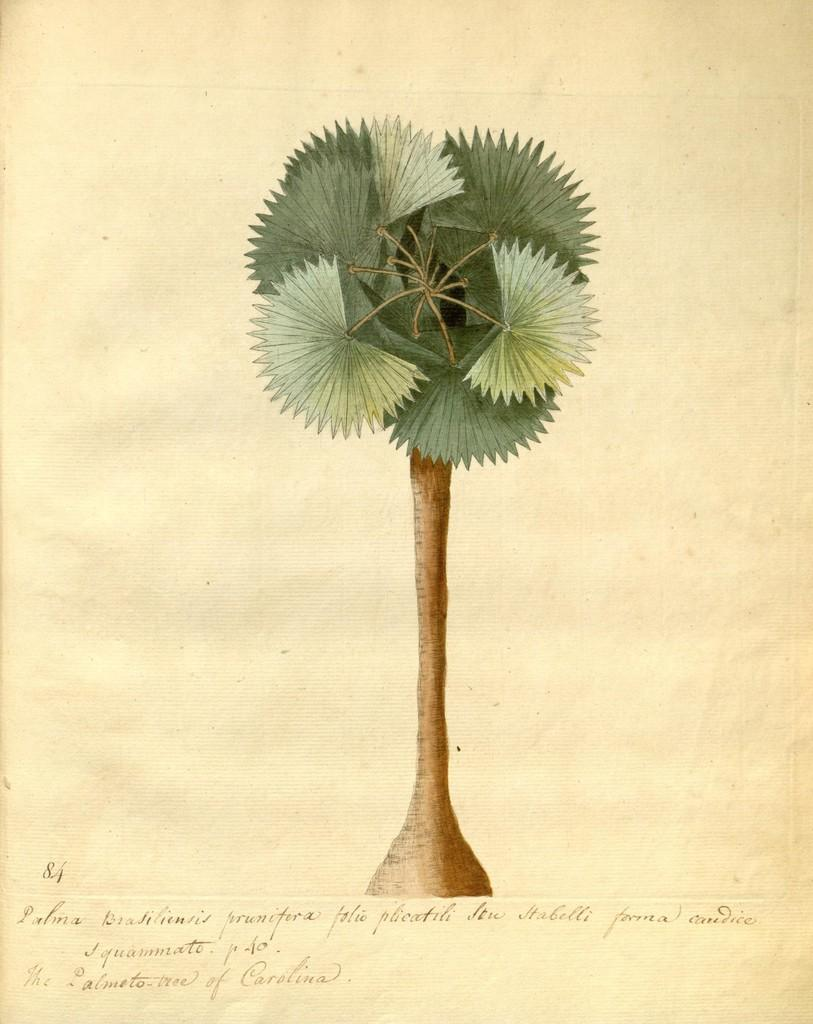What is the main subject of the image? The main subject of the image is a plant poster. Where is the plant poster located in the image? The plant poster is in the center of the image. What type of caption is written on the tub in the image? There is no tub present in the image, and therefore no caption can be found on it. 